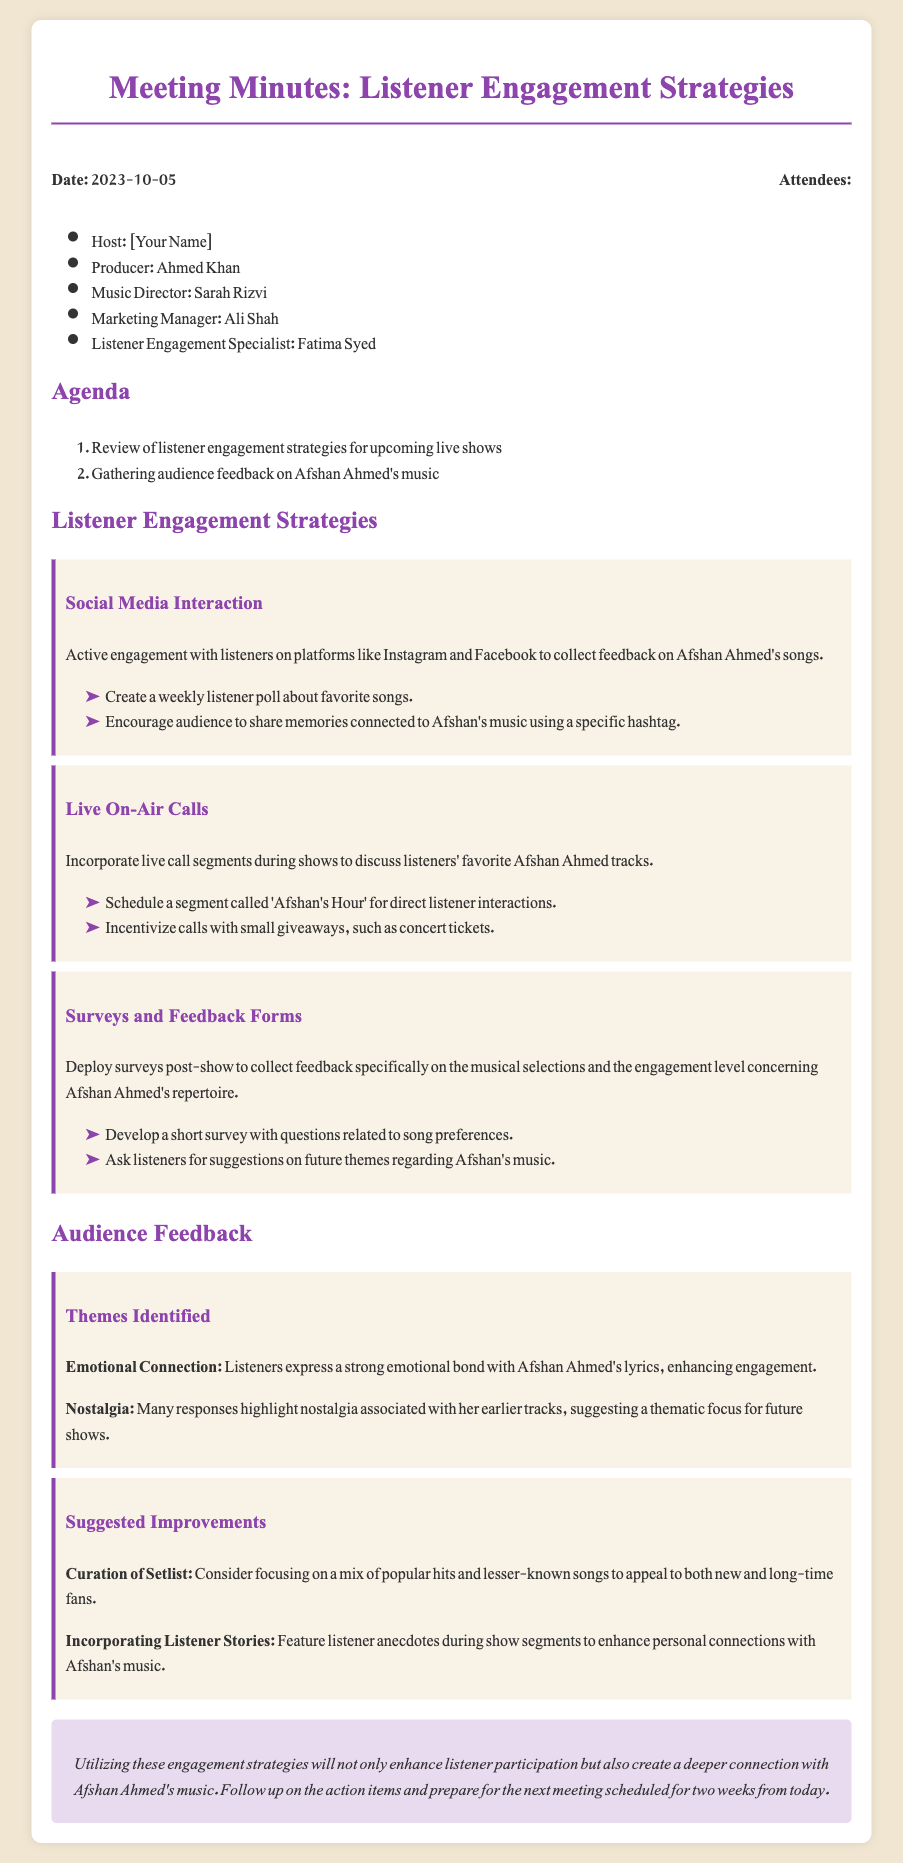what is the date of the meeting? The date of the meeting is explicitly mentioned at the beginning of the document.
Answer: 2023-10-05 who is the Listener Engagement Specialist? The document lists the attendees and their roles, highlighting the Listener Engagement Specialist.
Answer: Fatima Syed what is one of the suggested improvements for listener engagement? The document outlines suggested improvements for engagement connected to Afshan Ahmed's music.
Answer: Incorporating Listener Stories what segment is planned for live call interactions? The strategies section specifies a dedicated segment for listener interactions during live shows.
Answer: Afshan's Hour which social media platforms are mentioned for interaction? The strategies section lists the platforms intended for listener interaction, focusing on social media.
Answer: Instagram and Facebook how many attendees are listed in the meeting? The document provides a list of attendees, allowing us to count them directly.
Answer: 5 what emotional connection do listeners have with Afshan Ahmed's music? The feedback section describes a specific emotional aspect related to Afshan Ahmed's lyrics.
Answer: Strong emotional bond what type of feedback is collected after the shows? The document mentions a method for collecting feedback specifically related to musical selections.
Answer: Surveys and Feedback Forms what overall conclusion is drawn about the engagement strategies? The conclusion summarizes the expected outcome of implementing the strategies discussed in the meeting.
Answer: Enhance listener participation 